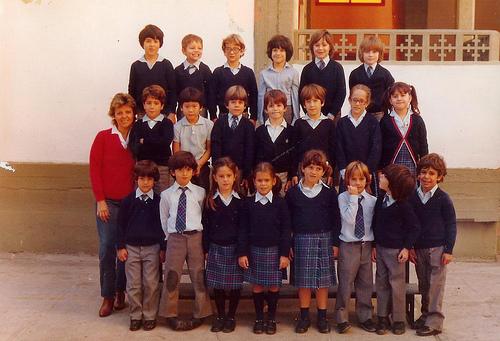Which jacket is different?
Keep it brief. Teachers. Which child is the most likely to be blamed for ruining the composition of this photograph?
Concise answer only. Child with his head turned. What are the kids wearing?
Be succinct. Uniforms. 